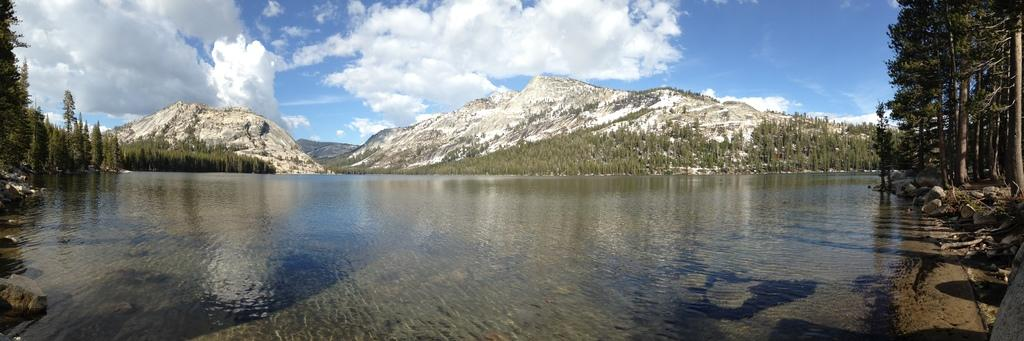What is one of the natural elements present in the image? There is water in the image. What type of objects can be seen in the water? There are stones in the image. What type of vegetation is present in the image? There are trees in the image. What type of geographical feature is present in the image? There are hills in the image. How would you describe the weather based on the image? The sky is cloudy in the image. What type of meat is being grilled on the barbecue in the image? There is no barbecue or meat present in the image. What type of skin condition can be seen on the person in the image? There is no person present in the image, so it is not possible to determine if they have any skin conditions. 